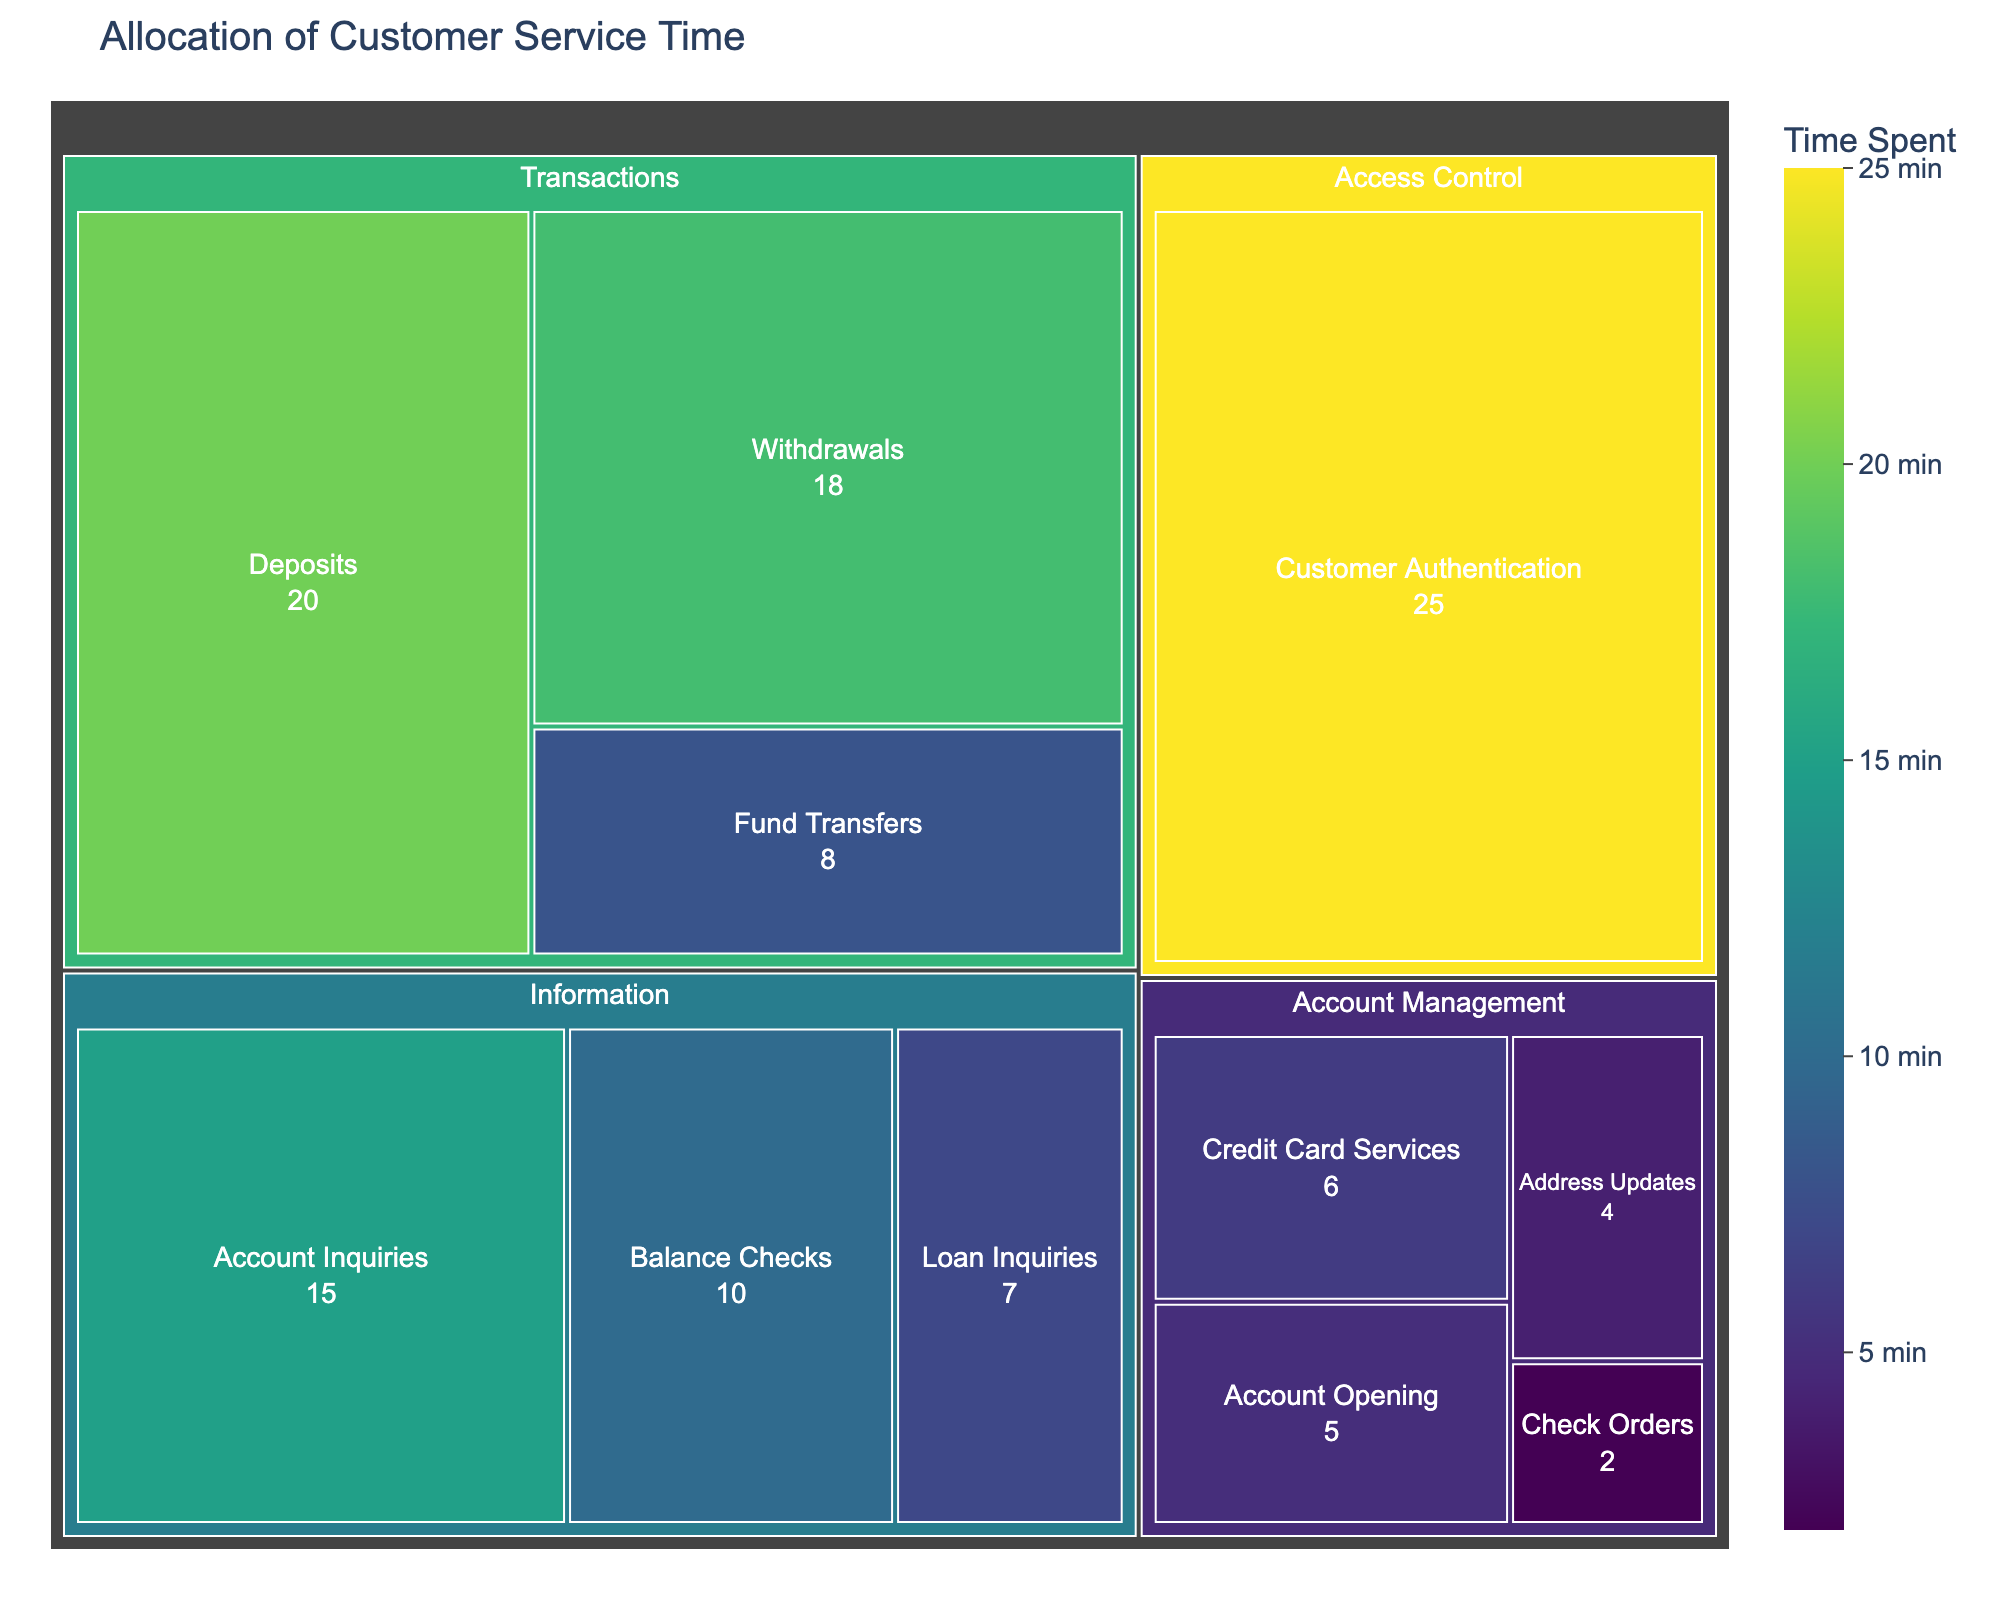What is the title of the figure? The title is clearly displayed at the top of the figure and indicates the purpose of the visualization.
Answer: Allocation of Customer Service Time Which banking activity takes the most time according to the figure? The largest section of the treemap, typically the one with the most prominent color, corresponds to the activity that takes the most time.
Answer: Customer Authentication How many minutes are spent on withdrawals? Locate the "Withdrawals" section within the treemap and read its time value.
Answer: 18 minutes What is the total time spent on account management activities? Sum up the times for all activities listed under the "Account Management" category: Credit Card Services (6), Account Opening (5), Address Updates (4), Check Orders (2). So, 6 + 5 + 4 + 2.
Answer: 17 minutes Which category has the least total time spent on its activities? Compare the total times for each listed category within the figure: Access Control (25), Transactions (20+18+8=46), Information (15+10+7=32), Account Management (17). The smallest total is found in the Access Control category.
Answer: Account Management What percentage of the total customer service time is allocated to deposits? Calculate the total time from all activities (25+20+18+15+10+8+7+6+5+4+2 = 120). The time for deposits is 20. Compute the percentage: (20/120) * 100.
Answer: 16.7% Arrange the banking activities from most to least time-consuming. List all activities and their times, then arrange them in descending order of time. The order is: Customer Authentication (25), Deposits (20), Withdrawals (18), Account Inquiries (15), Balance Checks (10), Fund Transfers (8), Loan Inquiries (7), Credit Card Services (6), Account Opening (5), Address Updates (4), Check Orders (2).
Answer: Customer Authentication, Deposits, Withdrawals, Account Inquiries, Balance Checks, Fund Transfers, Loan Inquiries, Credit Card Services, Account Opening, Address Updates, Check Orders What is the proportion of time spent on transactions-related activities to the total time? Sum the time for all "Transactions" activities (Deposits, Withdrawals, Fund Transfers): 20 + 18 + 8 = 46. Calculate the total time as 120. Compute the proportion (46/120).
Answer: 38.3% Which activity under the "Information" category takes the least time? Within the category "Information," compare the times: Account Inquiries (15), Balance Checks (10), Loan Inquiries (7). The smallest value corresponds to the activity that takes the least time.
Answer: Loan Inquiries 